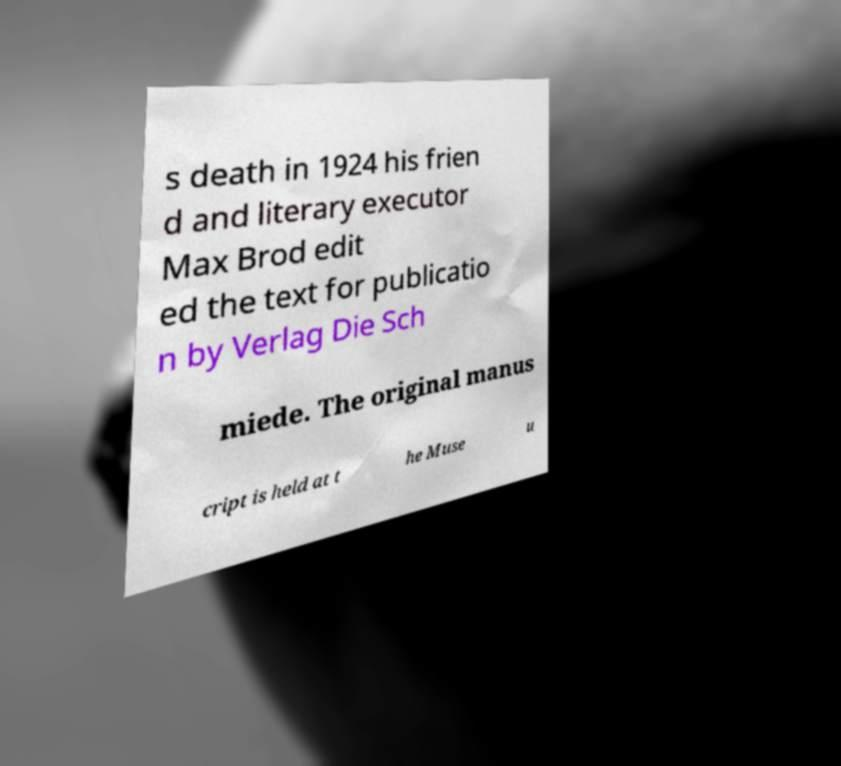Please read and relay the text visible in this image. What does it say? s death in 1924 his frien d and literary executor Max Brod edit ed the text for publicatio n by Verlag Die Sch miede. The original manus cript is held at t he Muse u 